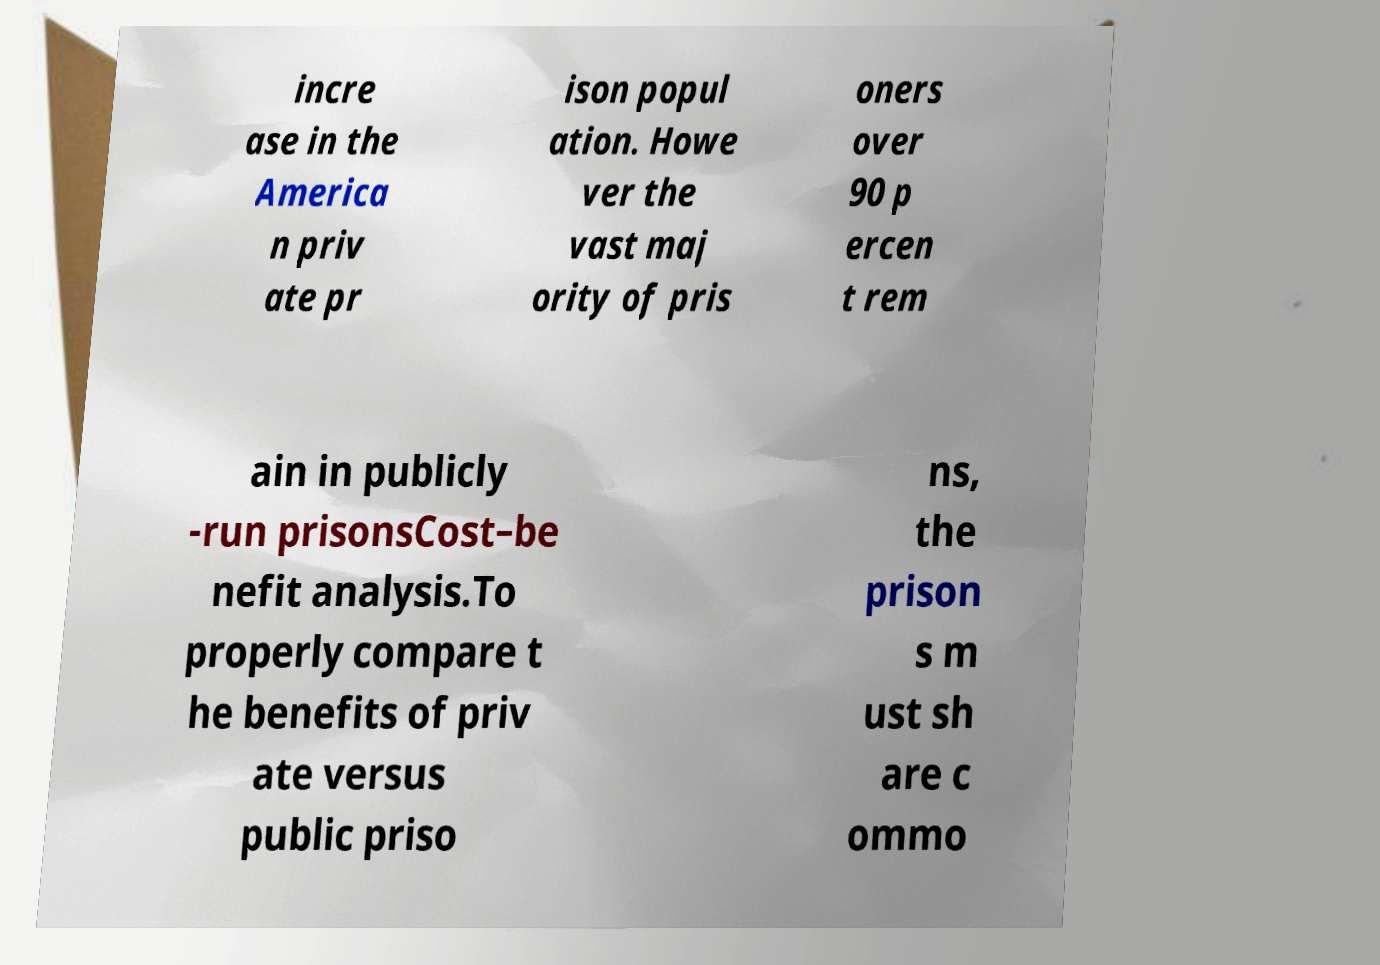What messages or text are displayed in this image? I need them in a readable, typed format. incre ase in the America n priv ate pr ison popul ation. Howe ver the vast maj ority of pris oners over 90 p ercen t rem ain in publicly -run prisonsCost–be nefit analysis.To properly compare t he benefits of priv ate versus public priso ns, the prison s m ust sh are c ommo 